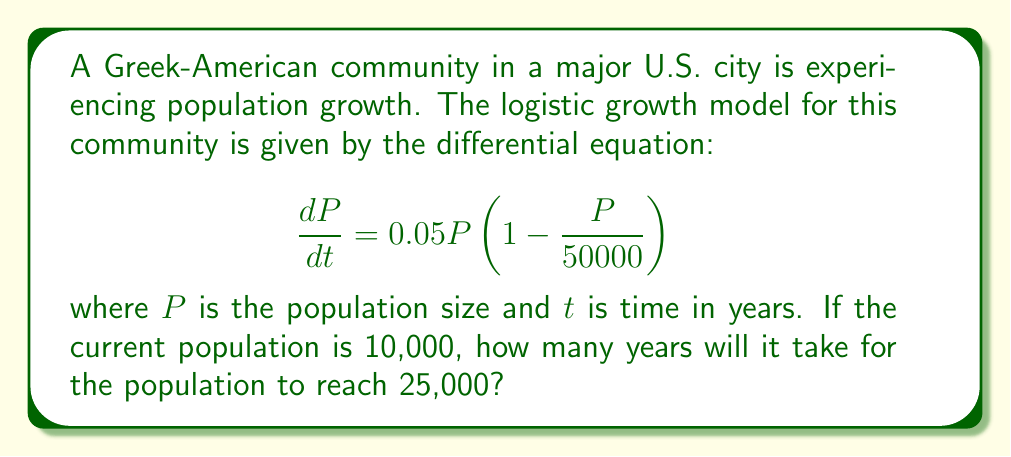Help me with this question. To solve this problem, we need to use the logistic growth model and integrate it to find the time required. Let's follow these steps:

1) The logistic growth model is given by:
   $$\frac{dP}{dt} = rP(1 - \frac{P}{K})$$
   where $r$ is the growth rate and $K$ is the carrying capacity.

2) In our case, $r = 0.05$ and $K = 50000$.

3) The solution to this differential equation is:
   $$P(t) = \frac{K}{1 + (\frac{K}{P_0} - 1)e^{-rt}}$$
   where $P_0$ is the initial population.

4) We need to find $t$ when $P(t) = 25000$. Let's substitute the known values:
   $$25000 = \frac{50000}{1 + (\frac{50000}{10000} - 1)e^{-0.05t}}$$

5) Simplify:
   $$25000 = \frac{50000}{1 + 4e^{-0.05t}}$$

6) Solve for $e^{-0.05t}$:
   $$1 + 4e^{-0.05t} = 2$$
   $$4e^{-0.05t} = 1$$
   $$e^{-0.05t} = \frac{1}{4}$$

7) Take the natural log of both sides:
   $$-0.05t = \ln(\frac{1}{4}) = -\ln(4)$$

8) Solve for $t$:
   $$t = \frac{\ln(4)}{0.05} \approx 27.73$$

Therefore, it will take approximately 27.73 years for the population to reach 25,000.
Answer: 27.73 years 